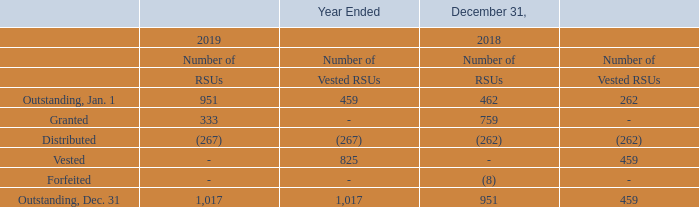Restricted Stock Unit Award Plans
We have two Restricted Stock Unit Award Plans for our employees and non-employee directors, a 2017 Restricted Stock Unit Award Plan (the “2017 RSU Plan”) and a 2014 Restricted Stock Unit Award Plan (the “2014 RSU Plan”). Vesting of an RSU entitles the holder to receive a share of our common stock on a distribution date. Our non-employee director awards allow for non-employee directors to receive payment in cash, instead of stock, for up to 40% of each RSU award. The portion of the RSU awards subject to cash settlement are recorded as a liability in the Company’s consolidated balance sheet as they vest and being marked-to-market each reporting period until they are distributed. The liability was $29 thousand and $11 thousand at December 31, 2019 and 2018, respectively.
The compensation cost to be incurred on a granted RSU without a cash settlement option is the RSU’s fair value, which is the market price of our common stock on the date of grant, less its exercise cost. The compensation cost is amortized to expense and recorded to additional paid-in capital over the vesting period of the RSU award.
A summary of the grants under the RSU Plans as of December 31, 2019 and 2018, and for the year then ended consisted of the following (in thousands):
What are the two restricted stock unit award plans for employee and non-employee directors? We have two restricted stock unit award plans for our employees and non-employee directors, a 2017 restricted stock unit award plan (the “2017 rsu plan”) and a 2014 restricted stock unit award plan (the “2014 rsu plan”). What was the RSU liability for non-employee directors in 2019 and 2018? The liability was $29 thousand and $11 thousand at december 31, 2019 and 2018, respectively. What is the ending outstanding number of vested RSUs in 2019?
Answer scale should be: thousand. 1,017. What is the difference between ending outstanding balance of RSUs and Vested RSUs in 2018?
Answer scale should be: thousand. 951 - 459 
Answer: 492. What is the difference between the number of RSUs granted in 2019 and 2018?
Answer scale should be: thousand. 759 - 333 
Answer: 426. What is the percentage increase in number of RSUs from 2018 to 2019?
Answer scale should be: percent. (1,017 - 951) / 951 
Answer: 6.94. 